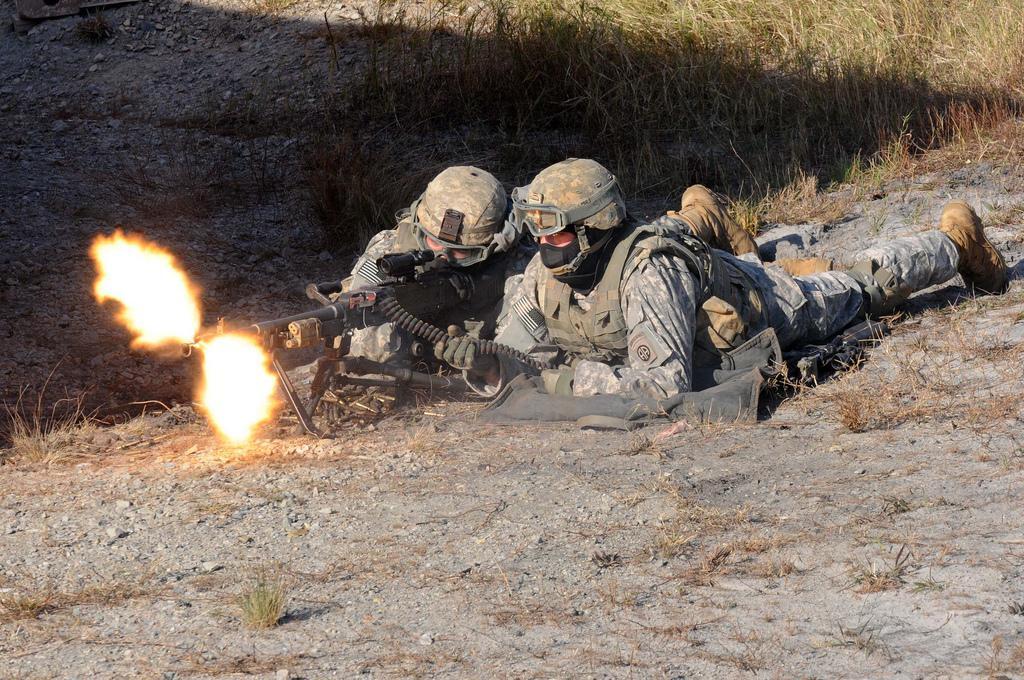In one or two sentences, can you explain what this image depicts? This picture is clicked outside. In the center we can see a person wearing a uniform, holding a rifle and lying on the ground and we can see another person wearing a uniform and lying on the ground and we can see the rifle releasing the flames. In the background we can see the grass and the ground. 